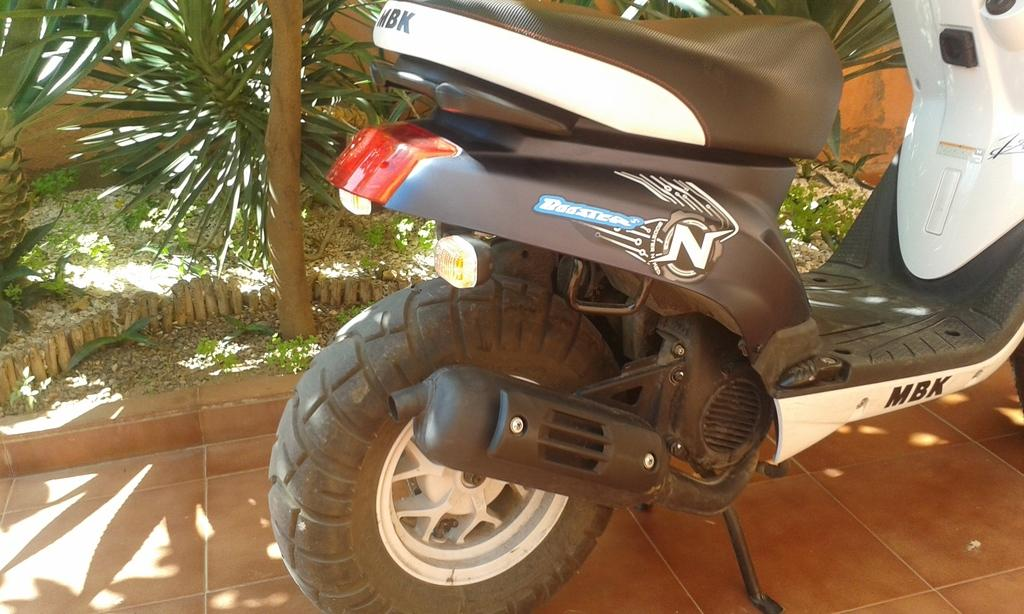What is parked in the image? There is a vehicle parked in the image. What is at the bottom of the image? There is a floor at the bottom of the image. What can be seen in the background of the image? There are plants in the background of the image. How many eggs are visible in the image? There are no eggs present in the image. What type of trees can be seen in the image? The provided facts do not mention any trees in the image. 